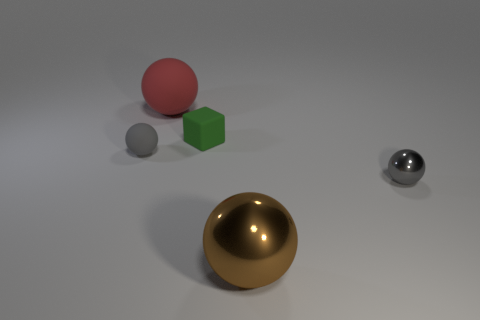Does the big thing that is to the right of the red matte thing have the same shape as the thing that is left of the large rubber thing?
Make the answer very short. Yes. The other shiny object that is the same shape as the brown shiny thing is what color?
Ensure brevity in your answer.  Gray. There is a gray rubber object that is the same shape as the tiny gray shiny object; what size is it?
Provide a short and direct response. Small. Do the red rubber object and the green rubber block have the same size?
Your answer should be very brief. No. How many objects are either small gray shiny spheres or matte objects?
Provide a succinct answer. 4. Are there an equal number of brown metallic spheres that are behind the brown object and tiny green cubes?
Make the answer very short. No. Is there a object behind the small matte object that is to the right of the tiny ball that is on the left side of the big metallic ball?
Your answer should be very brief. Yes. There is another sphere that is made of the same material as the red ball; what is its color?
Offer a terse response. Gray. There is a small ball that is behind the small gray shiny sphere; is it the same color as the big matte ball?
Your answer should be compact. No. What number of cylinders are either tiny brown objects or small gray matte objects?
Ensure brevity in your answer.  0. 